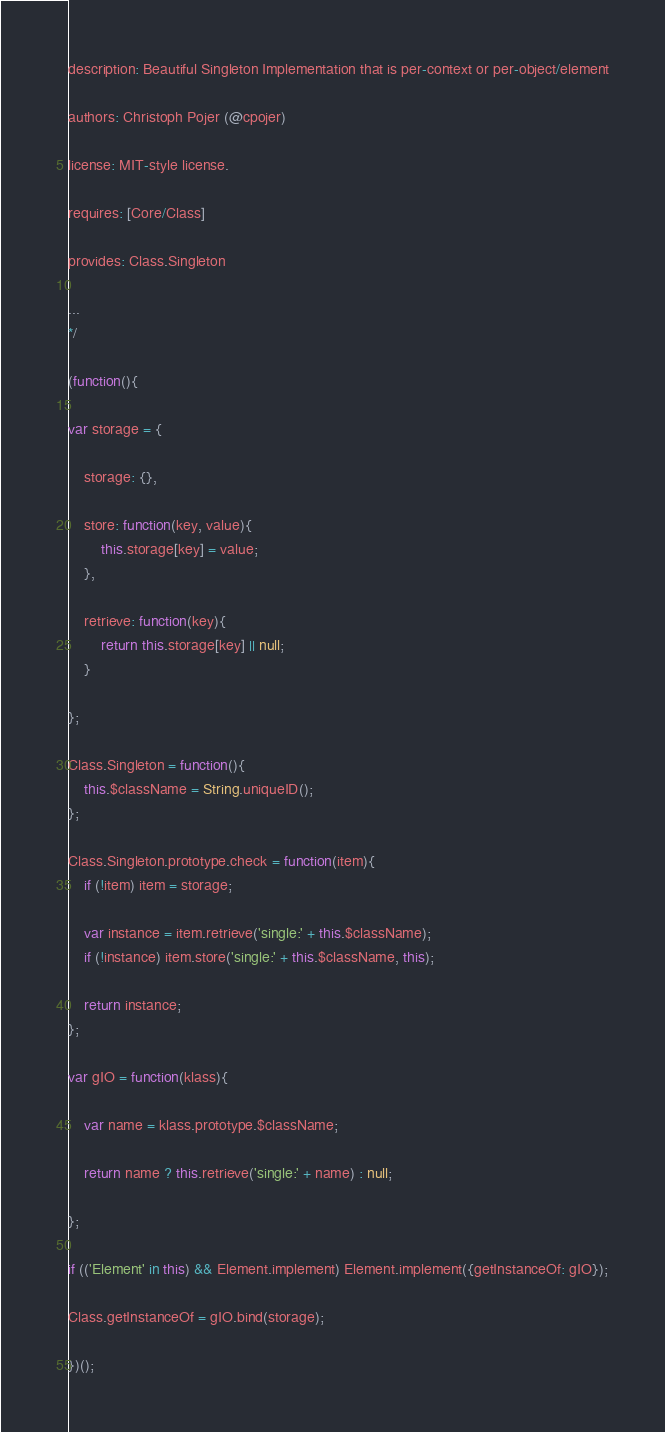Convert code to text. <code><loc_0><loc_0><loc_500><loc_500><_JavaScript_>
description: Beautiful Singleton Implementation that is per-context or per-object/element

authors: Christoph Pojer (@cpojer)

license: MIT-style license.

requires: [Core/Class]

provides: Class.Singleton

...
*/

(function(){

var storage = {

	storage: {},

	store: function(key, value){
		this.storage[key] = value;
	},

	retrieve: function(key){
		return this.storage[key] || null;
	}

};

Class.Singleton = function(){
	this.$className = String.uniqueID();
};

Class.Singleton.prototype.check = function(item){
	if (!item) item = storage;

	var instance = item.retrieve('single:' + this.$className);
	if (!instance) item.store('single:' + this.$className, this);

	return instance;
};

var gIO = function(klass){

	var name = klass.prototype.$className;

	return name ? this.retrieve('single:' + name) : null;

};

if (('Element' in this) && Element.implement) Element.implement({getInstanceOf: gIO});

Class.getInstanceOf = gIO.bind(storage);

})();</code> 